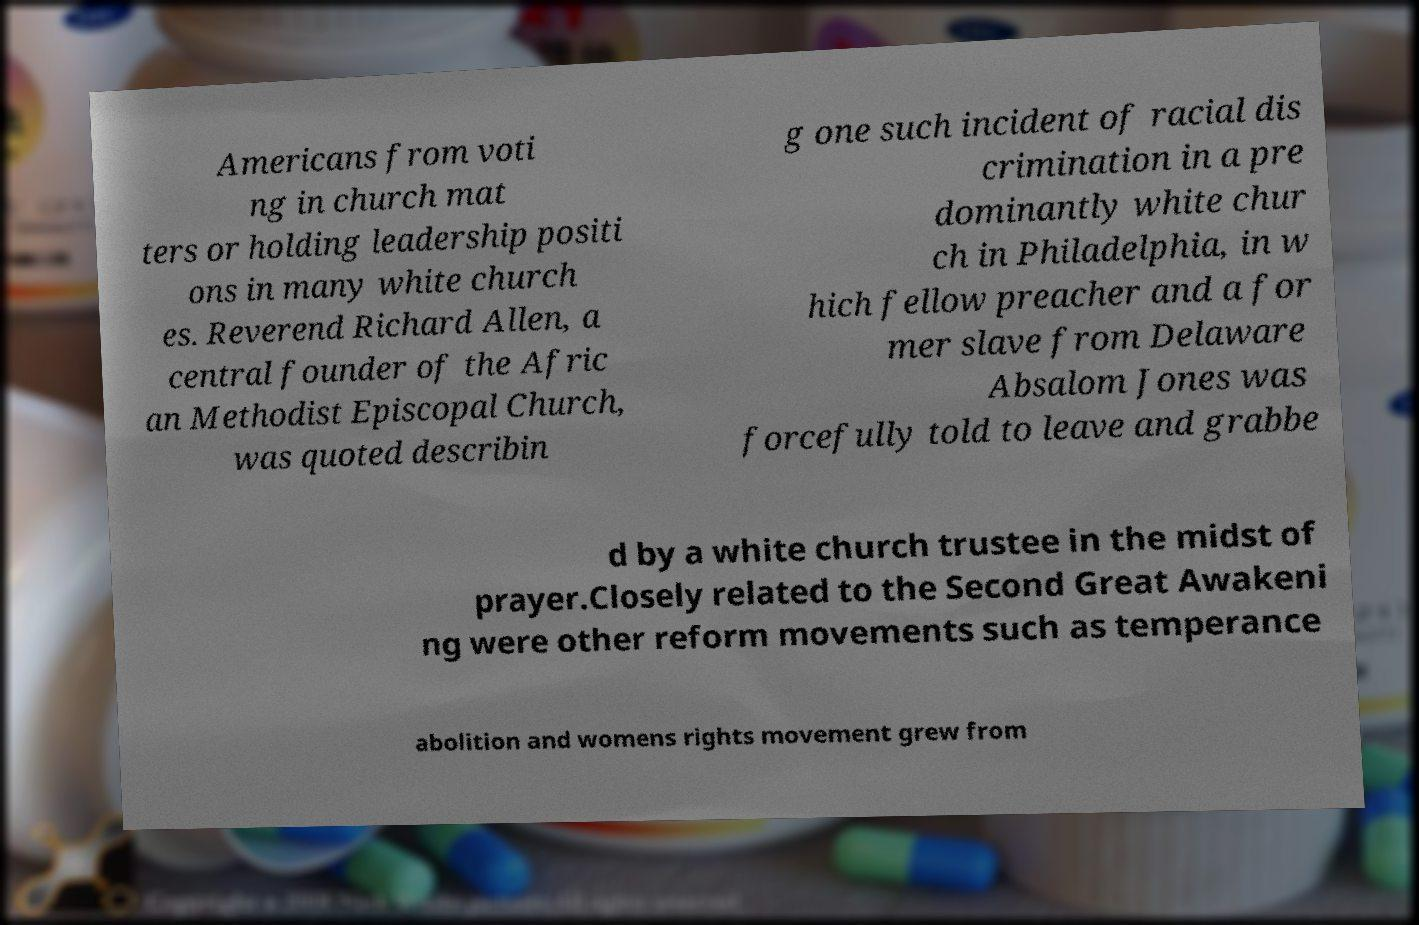Please identify and transcribe the text found in this image. Americans from voti ng in church mat ters or holding leadership positi ons in many white church es. Reverend Richard Allen, a central founder of the Afric an Methodist Episcopal Church, was quoted describin g one such incident of racial dis crimination in a pre dominantly white chur ch in Philadelphia, in w hich fellow preacher and a for mer slave from Delaware Absalom Jones was forcefully told to leave and grabbe d by a white church trustee in the midst of prayer.Closely related to the Second Great Awakeni ng were other reform movements such as temperance abolition and womens rights movement grew from 